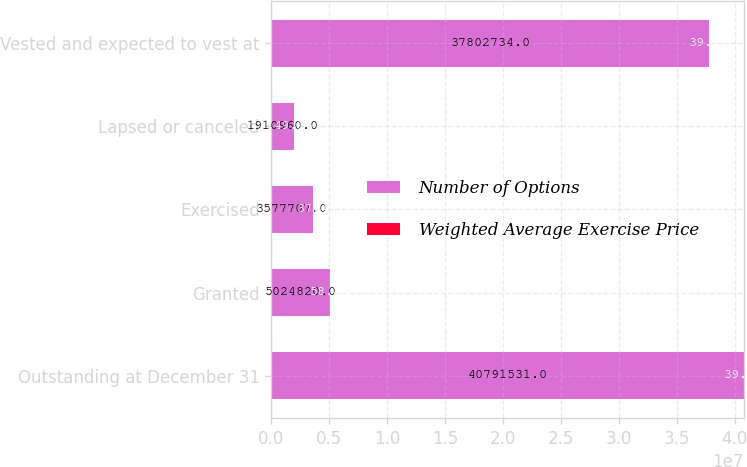<chart> <loc_0><loc_0><loc_500><loc_500><stacked_bar_chart><ecel><fcel>Outstanding at December 31<fcel>Granted<fcel>Exercised<fcel>Lapsed or canceled<fcel>Vested and expected to vest at<nl><fcel>Number of Options<fcel>4.07915e+07<fcel>5.02482e+06<fcel>3.57771e+06<fcel>1.91096e+06<fcel>3.78027e+07<nl><fcel>Weighted Average Exercise Price<fcel>39.05<fcel>58.46<fcel>37.4<fcel>49.16<fcel>39.19<nl></chart> 